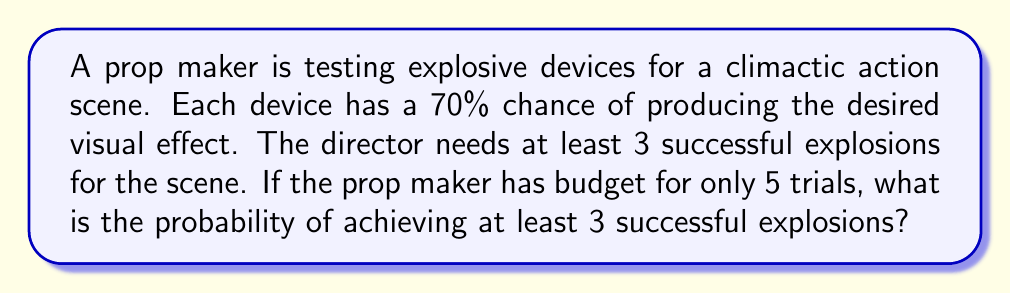Give your solution to this math problem. Let's approach this step-by-step using the binomial probability distribution:

1) We can model this scenario as a binomial distribution with parameters:
   $n = 5$ (number of trials)
   $p = 0.7$ (probability of success on each trial)
   $X$ = number of successful explosions

2) We need to find $P(X \geq 3)$, which is equivalent to:
   $P(X = 3) + P(X = 4) + P(X = 5)$

3) The probability mass function for a binomial distribution is:
   $P(X = k) = \binom{n}{k} p^k (1-p)^{n-k}$

4) Let's calculate each probability:

   For $k = 3$:
   $P(X = 3) = \binom{5}{3} (0.7)^3 (0.3)^2 = 10 \cdot 0.343 \cdot 0.09 = 0.3087$

   For $k = 4$:
   $P(X = 4) = \binom{5}{4} (0.7)^4 (0.3)^1 = 5 \cdot 0.2401 \cdot 0.3 = 0.3601$

   For $k = 5$:
   $P(X = 5) = \binom{5}{5} (0.7)^5 (0.3)^0 = 1 \cdot 0.16807 \cdot 1 = 0.16807$

5) Sum these probabilities:
   $P(X \geq 3) = 0.3087 + 0.3601 + 0.16807 = 0.83687$

6) Therefore, the probability of achieving at least 3 successful explosions in 5 trials is approximately 0.83687 or 83.69%.
Answer: 0.83687 